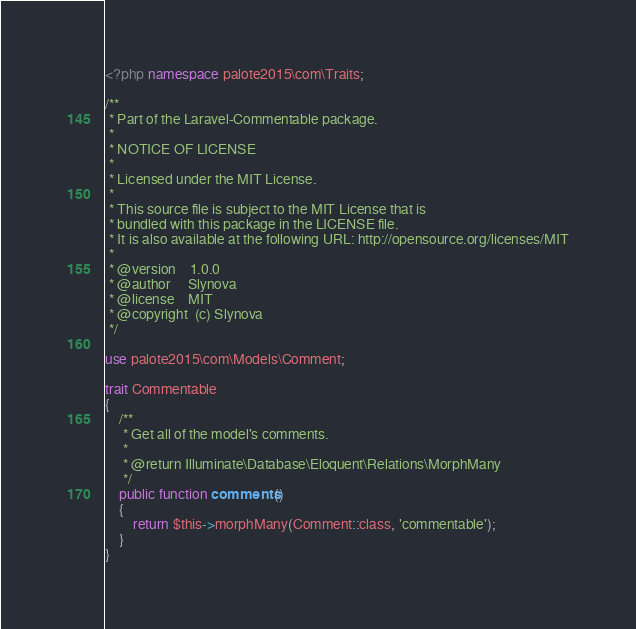<code> <loc_0><loc_0><loc_500><loc_500><_PHP_><?php namespace palote2015\com\Traits;

/**
 * Part of the Laravel-Commentable package.
 *
 * NOTICE OF LICENSE
 *
 * Licensed under the MIT License.
 *
 * This source file is subject to the MIT License that is
 * bundled with this package in the LICENSE file.
 * It is also available at the following URL: http://opensource.org/licenses/MIT
 *
 * @version    1.0.0
 * @author     Slynova
 * @license    MIT
 * @copyright  (c) Slynova
 */

use palote2015\com\Models\Comment;

trait Commentable
{
    /**
     * Get all of the model's comments.
     *
     * @return Illuminate\Database\Eloquent\Relations\MorphMany
     */
    public function comments()
    {
        return $this->morphMany(Comment::class, 'commentable');
    }
}
</code> 